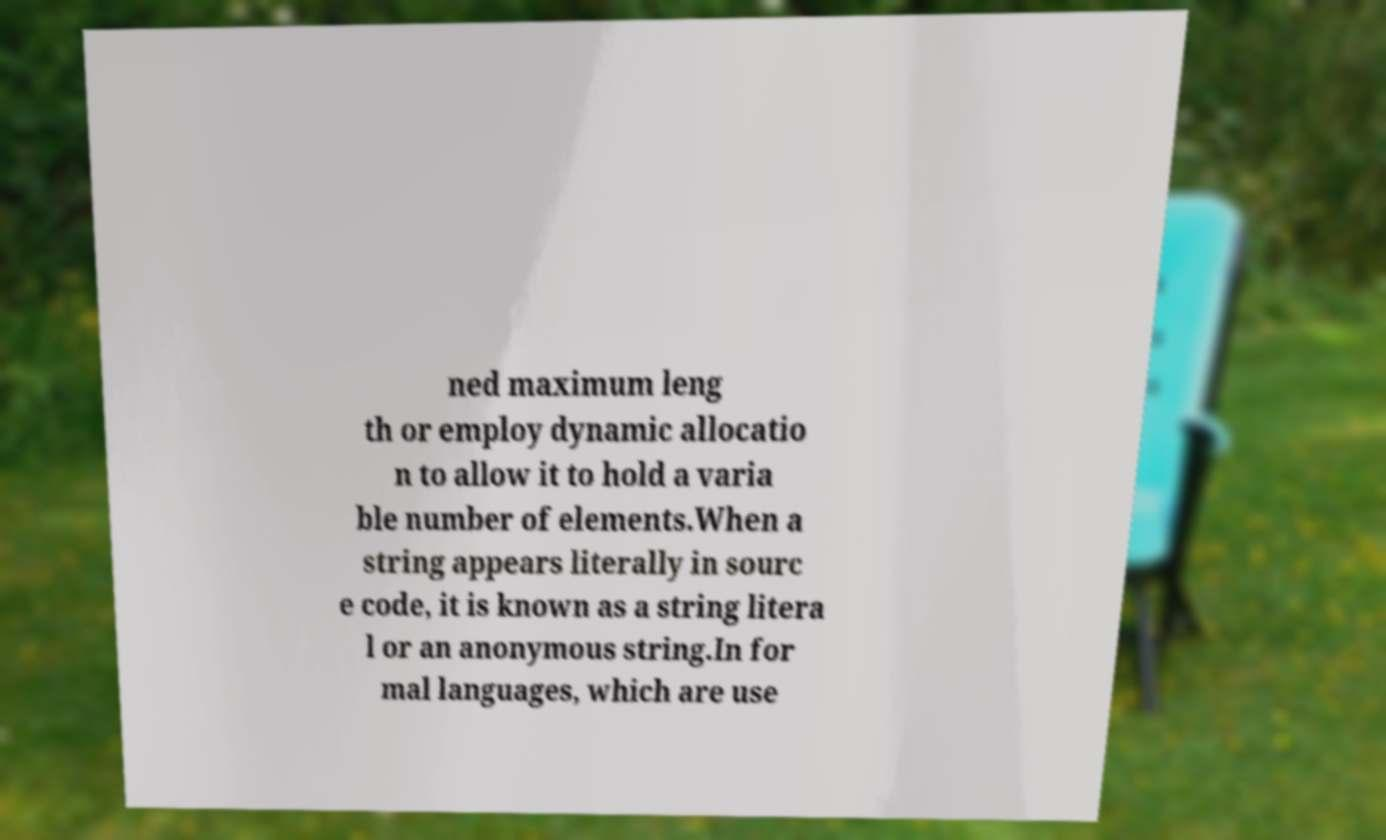I need the written content from this picture converted into text. Can you do that? ned maximum leng th or employ dynamic allocatio n to allow it to hold a varia ble number of elements.When a string appears literally in sourc e code, it is known as a string litera l or an anonymous string.In for mal languages, which are use 